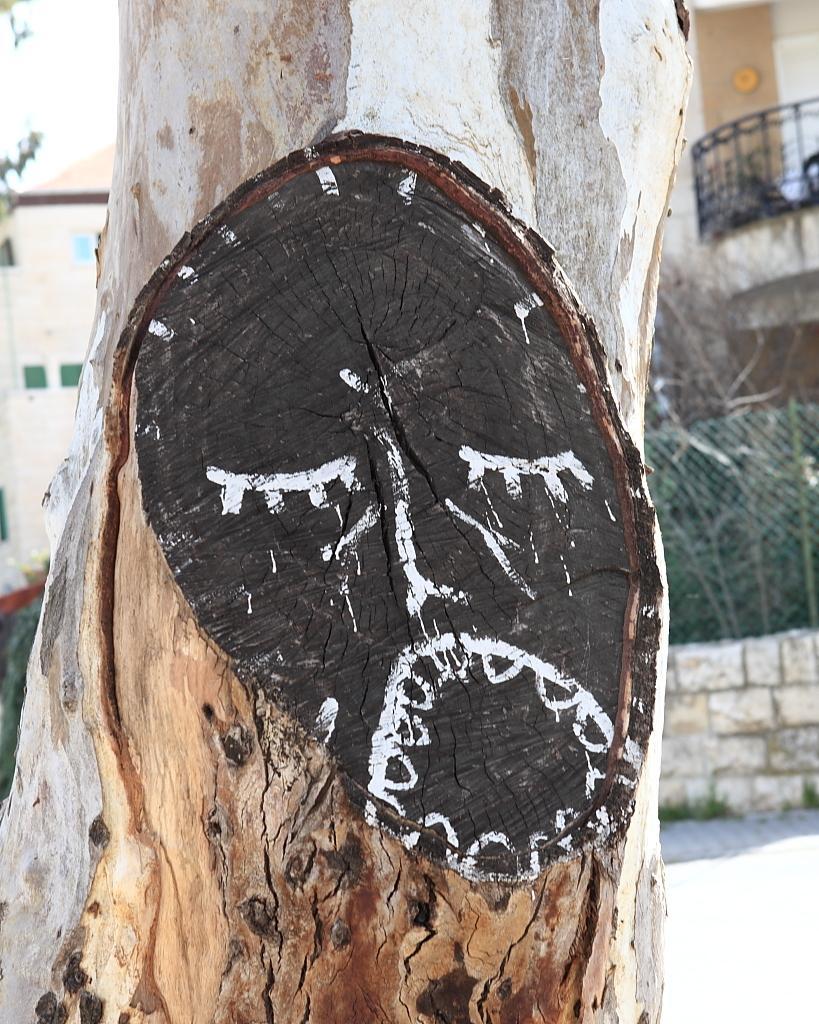Please provide a concise description of this image. This image consists of a tree. On the right, there is a wall and a fencing. In the background, there are buildings. At the bottom, there is a road. 